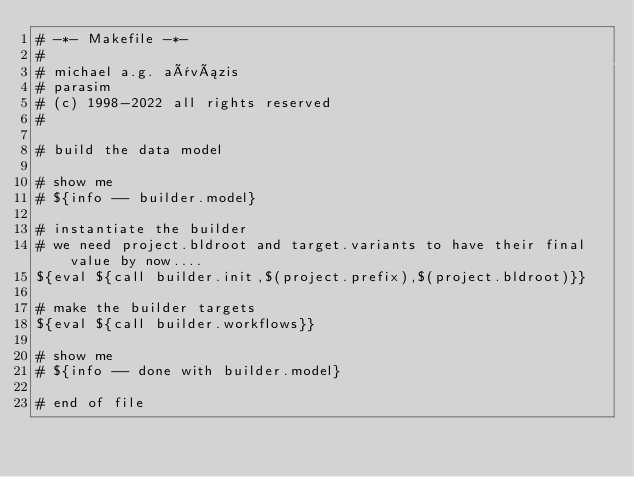<code> <loc_0><loc_0><loc_500><loc_500><_ObjectiveC_># -*- Makefile -*-
#
# michael a.g. aïvázis
# parasim
# (c) 1998-2022 all rights reserved
#

# build the data model

# show me
# ${info -- builder.model}

# instantiate the builder
# we need project.bldroot and target.variants to have their final value by now....
${eval ${call builder.init,$(project.prefix),$(project.bldroot)}}

# make the builder targets
${eval ${call builder.workflows}}

# show me
# ${info -- done with builder.model}

# end of file
</code> 